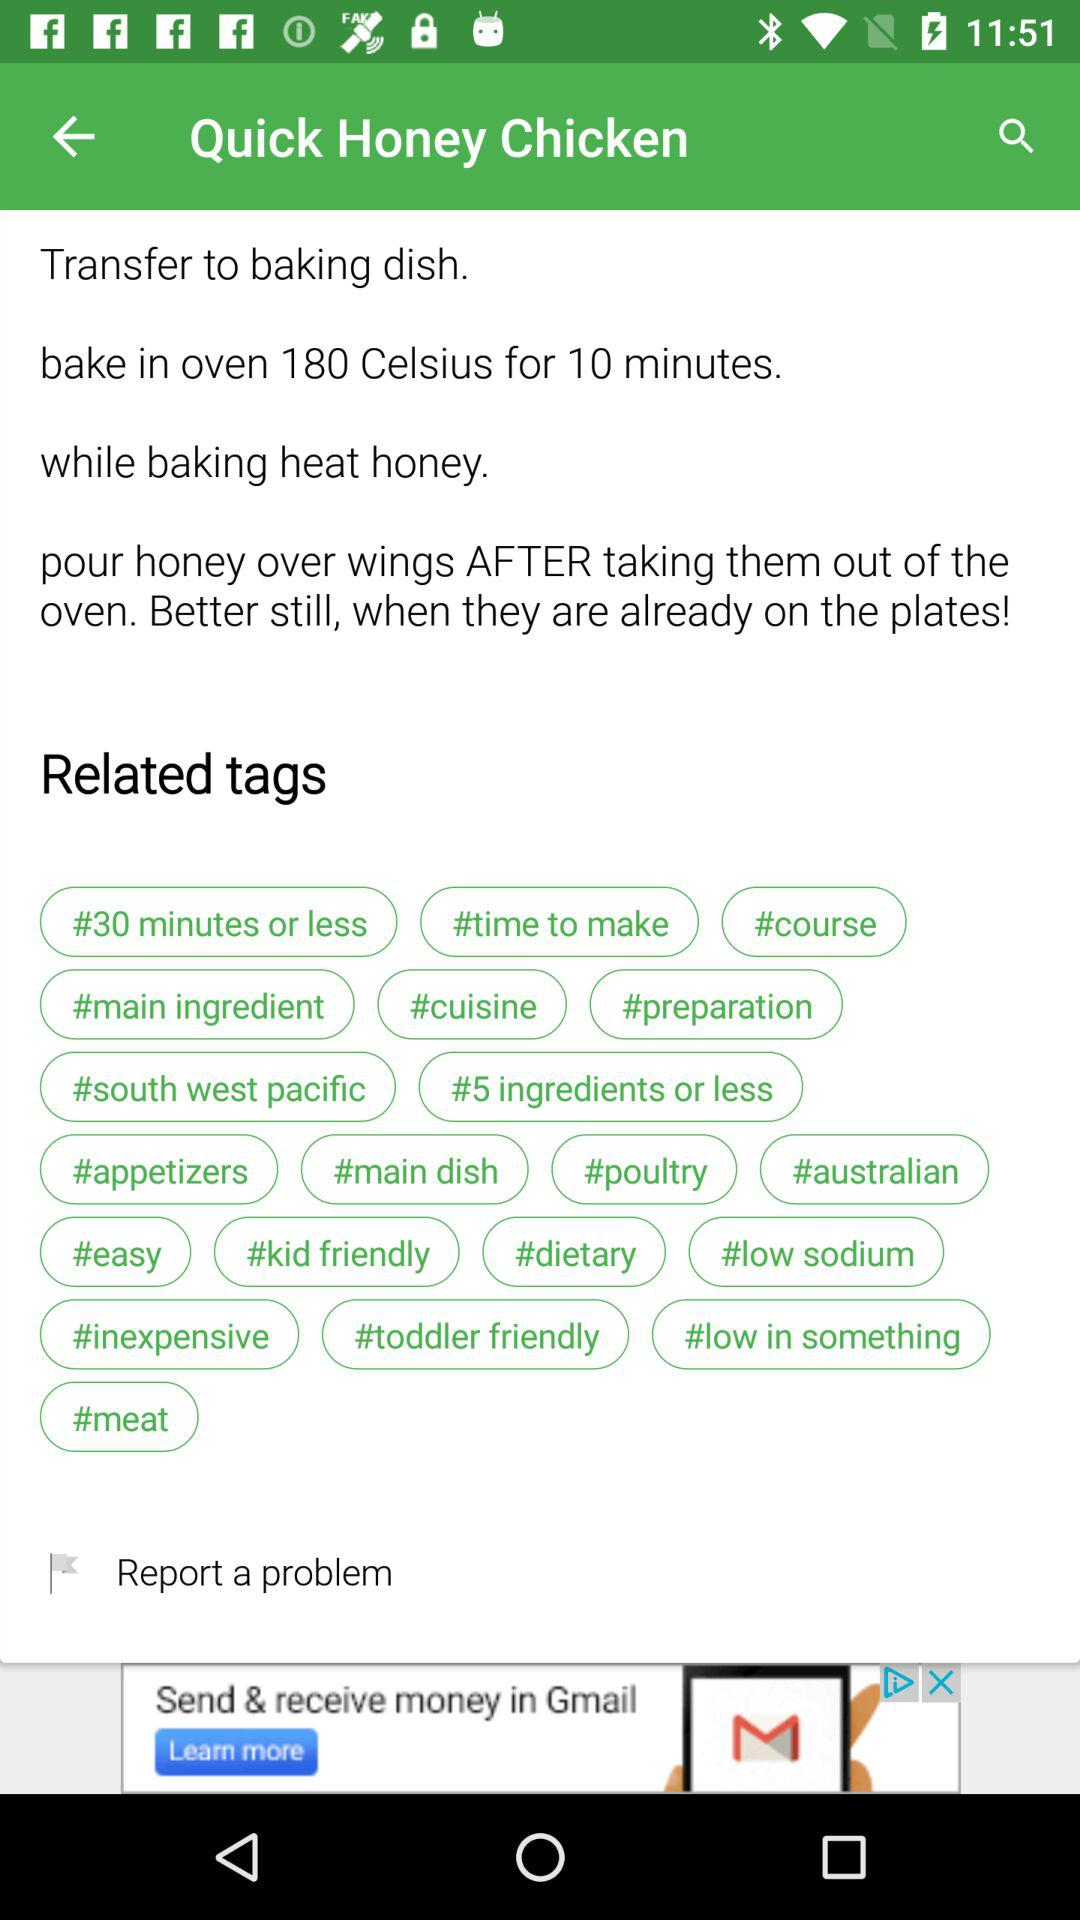For how many minutes should "Quick Honey Chicken" be baked in the oven? "Quick Honey Chicken" should be baked for 10 minutes. 